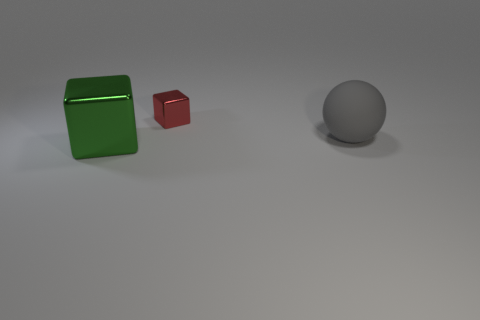Is there a large gray matte object?
Your answer should be compact. Yes. The thing that is on the right side of the tiny shiny block is what color?
Offer a terse response. Gray. There is a big thing to the right of the thing left of the small thing; how many large matte objects are to the right of it?
Make the answer very short. 0. There is a thing that is in front of the small shiny thing and on the left side of the large gray rubber thing; what material is it made of?
Offer a terse response. Metal. Is the gray ball made of the same material as the block that is in front of the small red block?
Keep it short and to the point. No. Are there more gray rubber balls that are in front of the big ball than large gray balls to the left of the green shiny object?
Keep it short and to the point. No. The red metal object has what shape?
Provide a succinct answer. Cube. Do the big thing that is left of the red object and the large thing that is to the right of the small thing have the same material?
Give a very brief answer. No. What shape is the metal object that is to the right of the large block?
Provide a short and direct response. Cube. There is a red object that is the same shape as the large green metallic thing; what size is it?
Give a very brief answer. Small. 